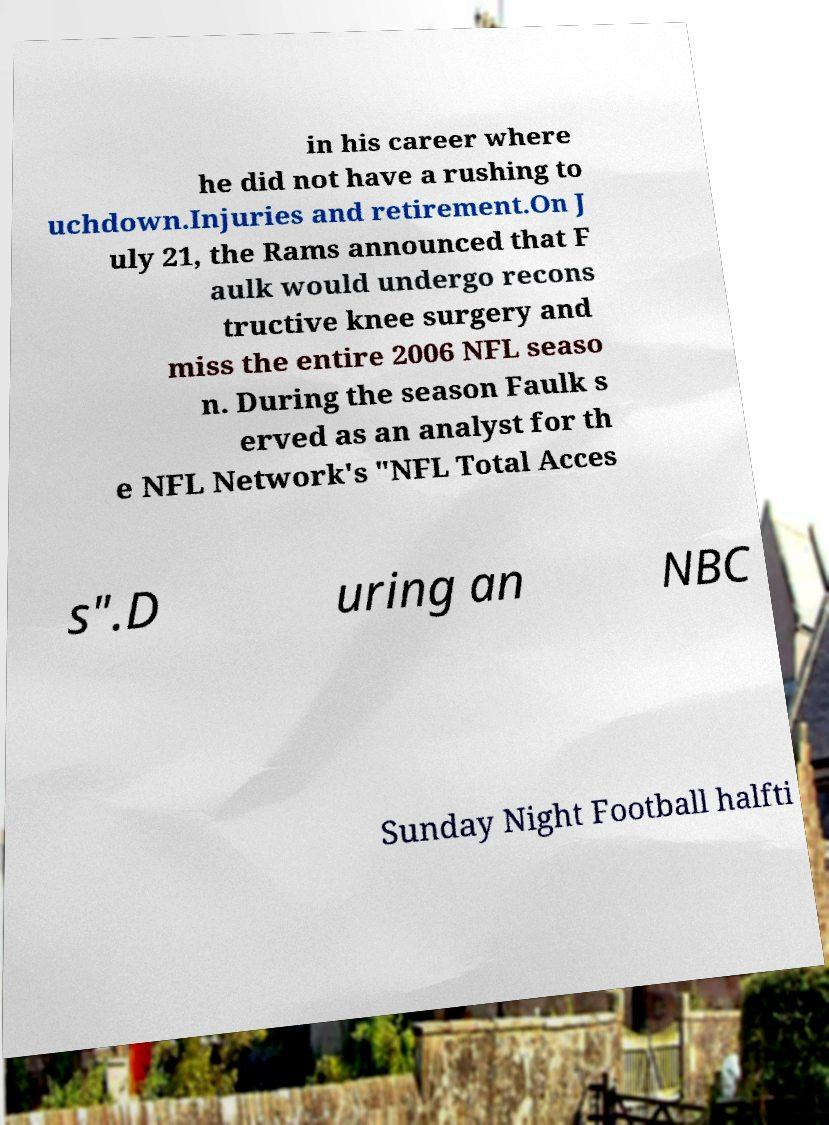What messages or text are displayed in this image? I need them in a readable, typed format. in his career where he did not have a rushing to uchdown.Injuries and retirement.On J uly 21, the Rams announced that F aulk would undergo recons tructive knee surgery and miss the entire 2006 NFL seaso n. During the season Faulk s erved as an analyst for th e NFL Network's "NFL Total Acces s".D uring an NBC Sunday Night Football halfti 